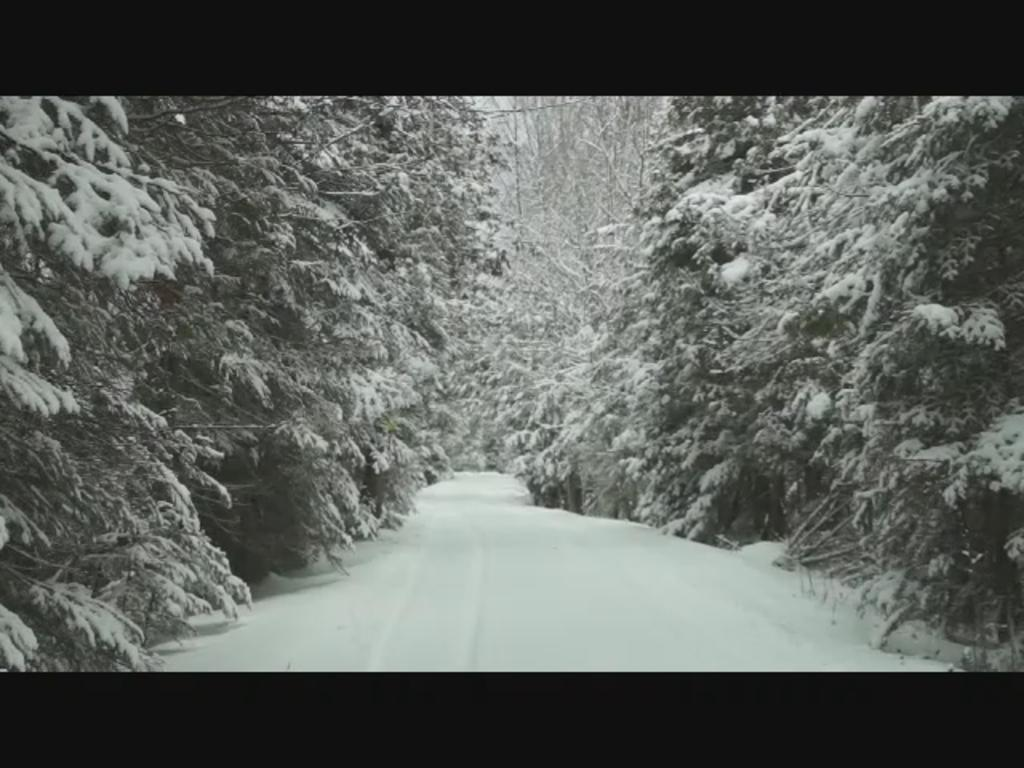What is the main feature of the image? There is a road in the image. What is the condition of the road? There is snow on the road. What can be seen on both sides of the road? There are trees on both sides of the road. What is the condition of the trees? There is snow on the trees. What type of division can be seen between the trees in the image? There is no division between the trees in the image; they are simply on both sides of the road. 